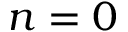<formula> <loc_0><loc_0><loc_500><loc_500>n = 0</formula> 